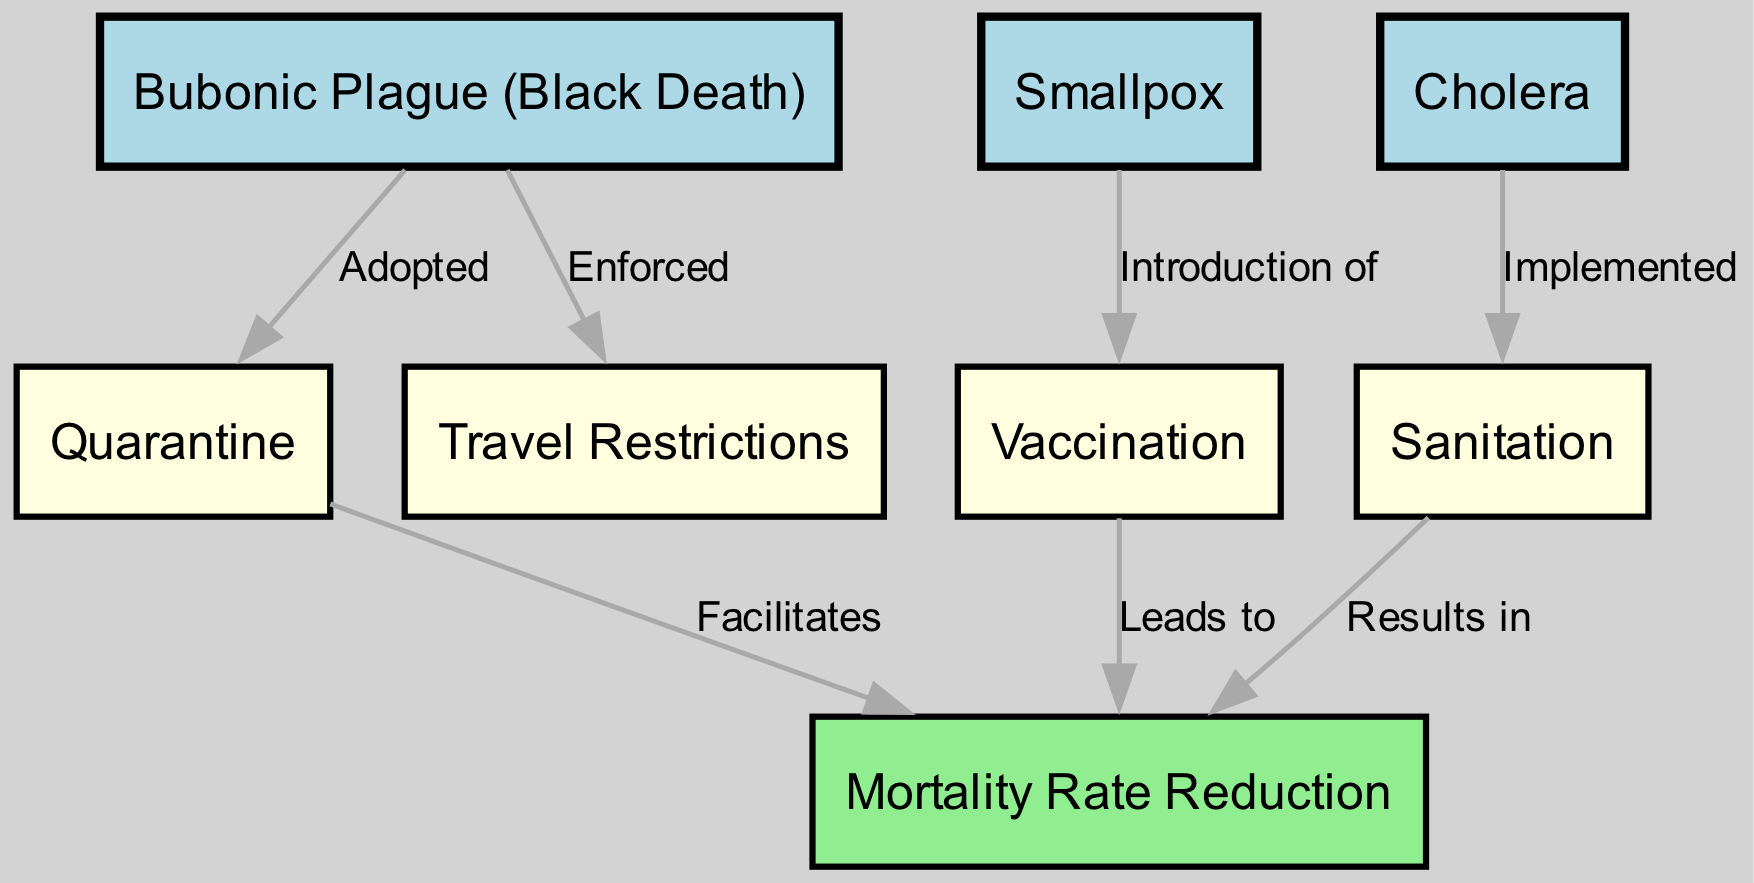What is the primary strategy adopted for the Bubonic Plague? The diagram indicates that the primary strategy for the Bubonic Plague was "Quarantine," which is directly connected to it as an adopted measure.
Answer: Quarantine How many infectious diseases are represented in this diagram? The diagram shows three infectious diseases: Bubonic Plague, Smallpox, and Cholera, counting directly from the nodes.
Answer: 3 Which containment strategy is introduced for Smallpox? The diagram specifies that "Vaccination" was introduced as a containment strategy for Smallpox, indicated by the directed edge connecting Smallpox to Vaccination.
Answer: Vaccination What result does the implementation of Sanitation lead to? According to the diagram, the implementation of "Sanitation" results in "Mortality Rate Reduction," directly connecting Sanitation to this outcome.
Answer: Mortality Rate Reduction What is the relationship between Quarantine and Mortality Rate Reduction? The diagram shows that Quarantine facilitates Mortality Rate Reduction, representing the causal relationship from Quarantine to this outcome.
Answer: Facilitates Which containment strategy was enforced alongside the Bubonic Plague? The diagram details that "Travel Restrictions" were enforced in addition to the quarantine measures during the Bubonic Plague epidemic.
Answer: Travel Restrictions How many edges are depicted in the diagram? By counting the directed connections from the edges section in the diagram, we find there are six edges connecting the various nodes.
Answer: 6 What is the primary outcome of both Vaccination and Sanitation strategies? The diagram indicates that both Vaccination and Sanitation lead to "Mortality Rate Reduction," emphasizing the common outcome of these strategies.
Answer: Mortality Rate Reduction Which disease's containment strategy involves the implementation of Sanitation? The diagram clearly states that Cholera's containment strategy involves the "Implementation of Sanitation," directly linking Cholera to this method.
Answer: Cholera 